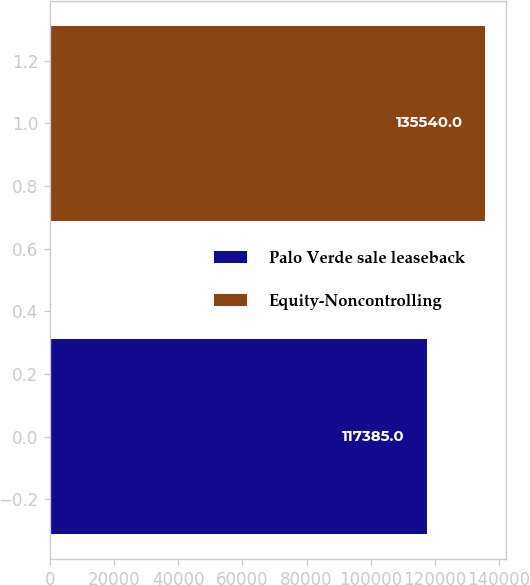Convert chart to OTSL. <chart><loc_0><loc_0><loc_500><loc_500><bar_chart><fcel>Palo Verde sale leaseback<fcel>Equity-Noncontrolling<nl><fcel>117385<fcel>135540<nl></chart> 